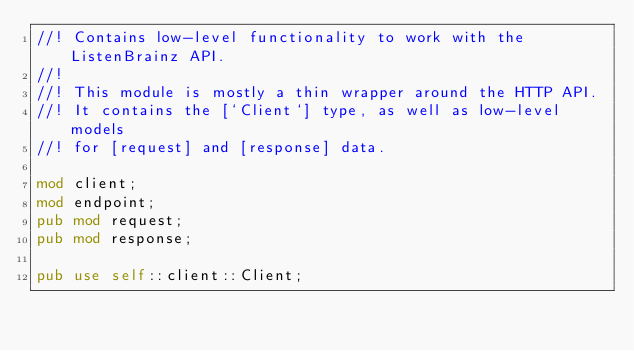<code> <loc_0><loc_0><loc_500><loc_500><_Rust_>//! Contains low-level functionality to work with the ListenBrainz API.
//!
//! This module is mostly a thin wrapper around the HTTP API.
//! It contains the [`Client`] type, as well as low-level models
//! for [request] and [response] data.

mod client;
mod endpoint;
pub mod request;
pub mod response;

pub use self::client::Client;
</code> 